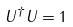<formula> <loc_0><loc_0><loc_500><loc_500>U ^ { \dagger } U = 1</formula> 